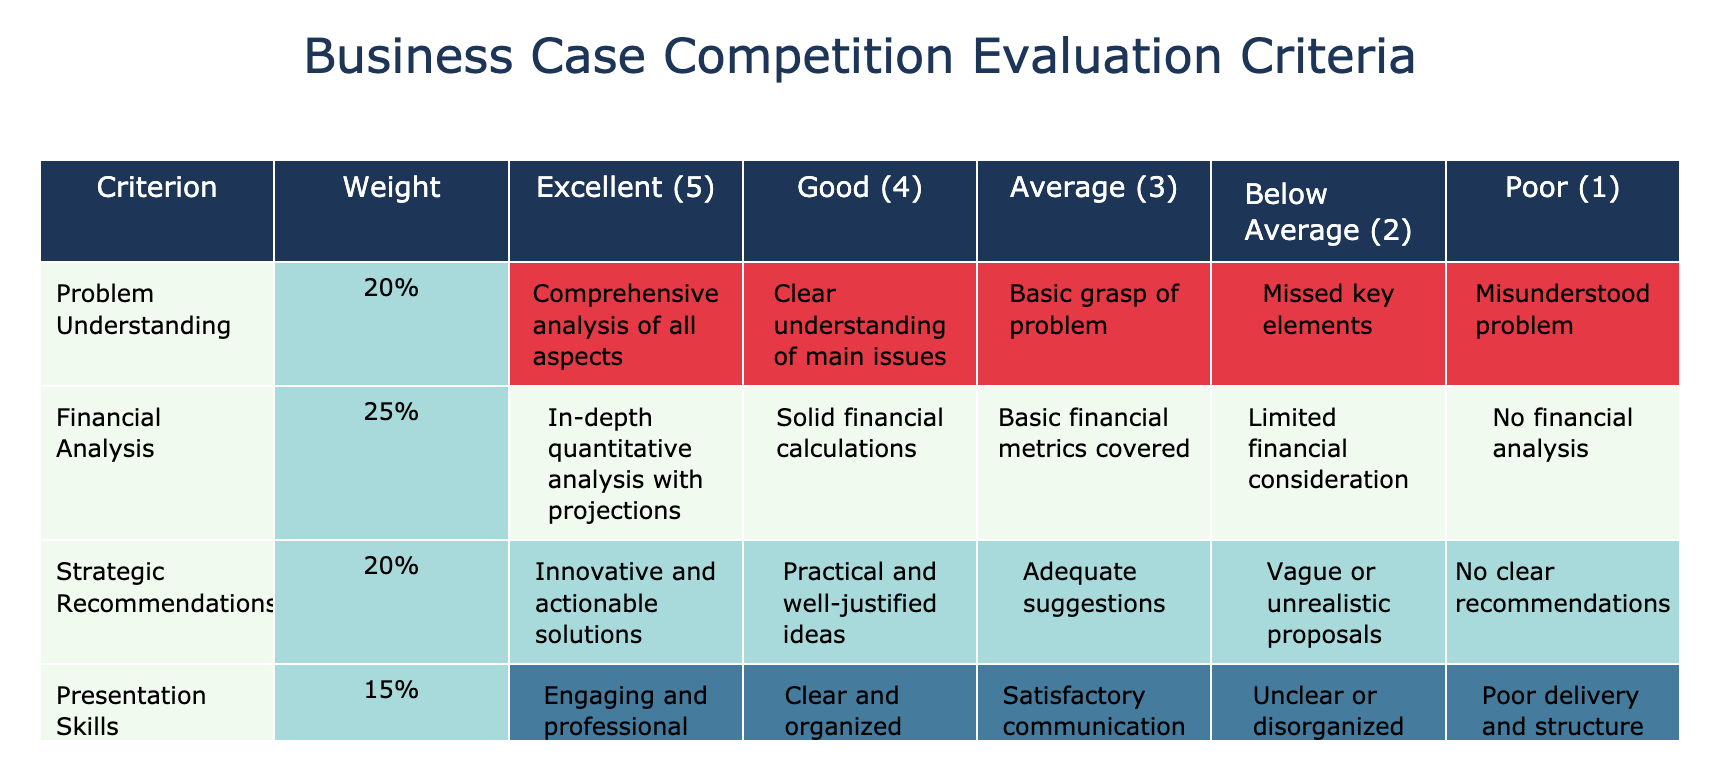What is the weight assigned to Problem Understanding? The table lists the weights for each criterion in the second column. For Problem Understanding, the weight is indicated as 20%.
Answer: 20% What are the criteria that have a weight of 20%? By looking at the weights in the second column, we can see that there are two criteria with a weight of 20%. They are Problem Understanding and Strategic Recommendations.
Answer: Problem Understanding and Strategic Recommendations Is the performance in Q&A more or less important than Presentation Skills? Comparing the weights in the table, Q&A Performance has a weight of 10% while Presentation Skills has a weight of 15%. Since 10% is less than 15%, Q&A Performance is less important.
Answer: Less important What is the combined weight of Financial Analysis and Presentation Skills? To find the combined weight, we add the weights of both criteria: Financial Analysis (25%) + Presentation Skills (15%) = 40%.
Answer: 40% How many criteria have a weight of 10% or less? The table shows weights for each criterion in the second column. We can count those with weights of 10% or less. The criteria are Q&A Performance (10%) and Team Collaboration (10%), totaling 2 criteria.
Answer: 2 Which criterion has the highest weight and what is it? By examining the weights in the second column, Financial Analysis has the highest weight at 25%.
Answer: Financial Analysis, 25% If a team received a rating of Excellent (5) in all criteria, what would be the total score? We first calculate the score for each criterion by multiplying the rating by its weight and summing these products. Scores are: Problem Understanding (5 * 20) + Financial Analysis (5 * 25) + Strategic Recommendations (5 * 20) + Presentation Skills (5 * 15) + Q&A Performance (5 * 10) + Team Collaboration (5 * 10) = 100.
Answer: 100 What is the minimum rating a team must achieve in Financial Analysis to avoid being rated Poor? The Poor rating corresponds to a score of 1, which is less than the minimum required for a basic financial assessment. Thus, to avoid a Poor rating, a team must at least score Average (3).
Answer: Average or better Does Team Collaboration have a higher or lower maximum rating than Presentation Skills? The maximum rating for both Team Collaboration and Presentation Skills is Excellent (5), so they have the same maximum rating.
Answer: Same maximum rating 